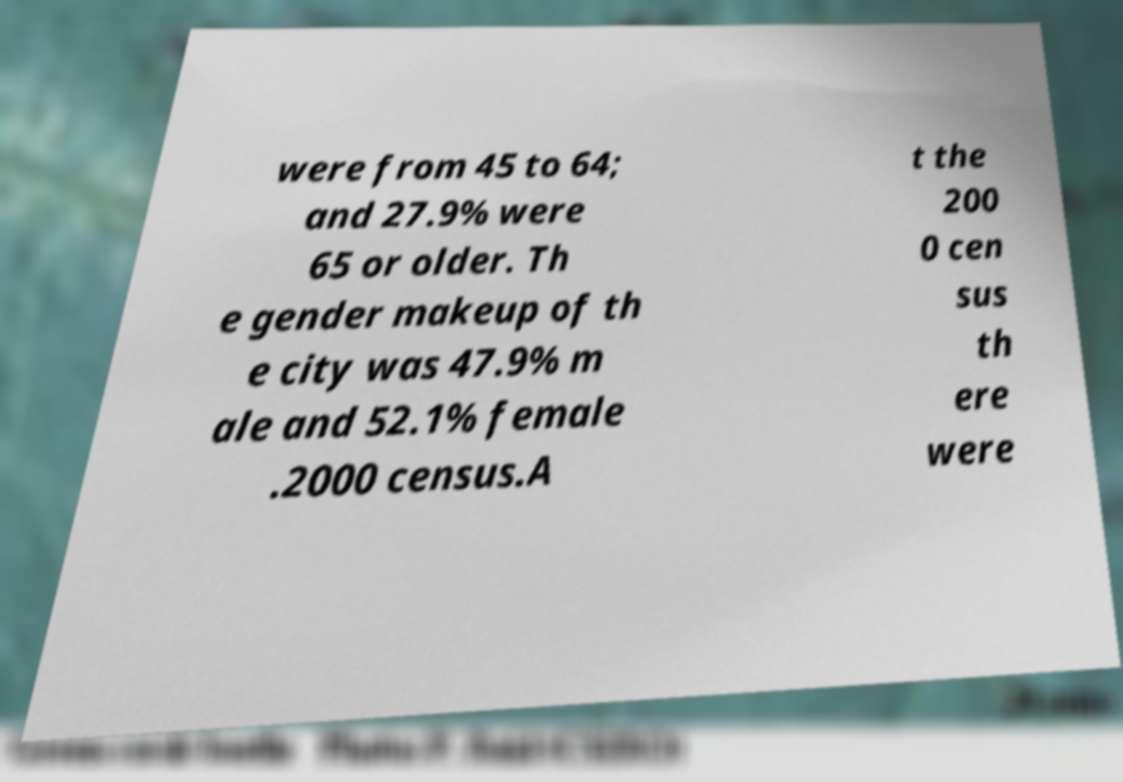Could you assist in decoding the text presented in this image and type it out clearly? were from 45 to 64; and 27.9% were 65 or older. Th e gender makeup of th e city was 47.9% m ale and 52.1% female .2000 census.A t the 200 0 cen sus th ere were 